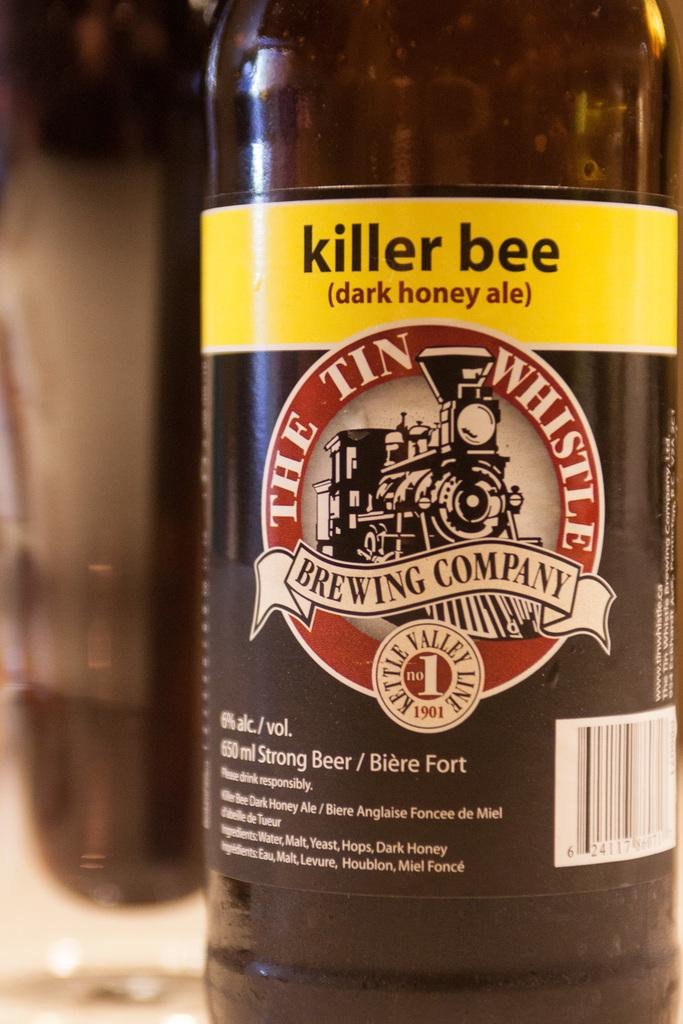Provide a one-sentence caption for the provided image. A bottle of killer bee dark honey ale from The Tin Whistle Brewing Company. 